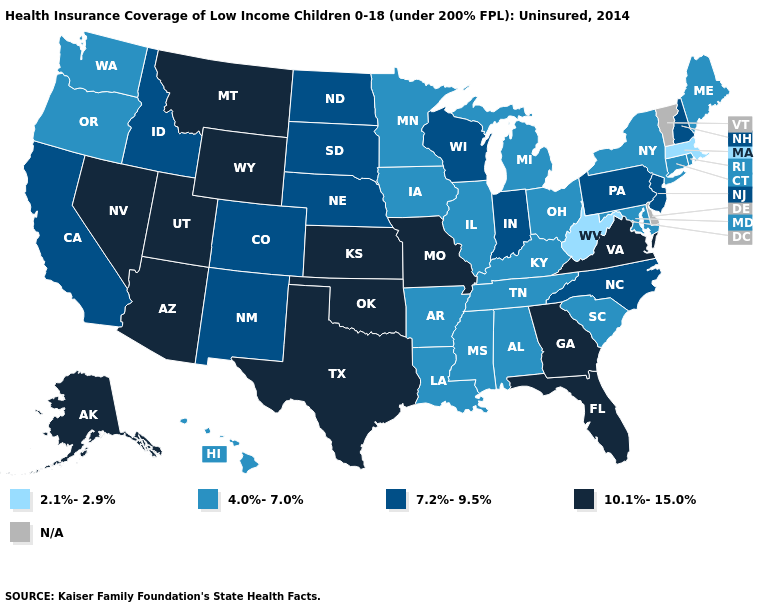Which states have the lowest value in the West?
Keep it brief. Hawaii, Oregon, Washington. How many symbols are there in the legend?
Keep it brief. 5. What is the highest value in the South ?
Short answer required. 10.1%-15.0%. What is the highest value in the USA?
Write a very short answer. 10.1%-15.0%. Which states have the lowest value in the USA?
Concise answer only. Massachusetts, West Virginia. What is the value of Nebraska?
Keep it brief. 7.2%-9.5%. Which states have the lowest value in the USA?
Give a very brief answer. Massachusetts, West Virginia. What is the value of Arizona?
Write a very short answer. 10.1%-15.0%. What is the highest value in the USA?
Answer briefly. 10.1%-15.0%. Among the states that border Oklahoma , does Missouri have the lowest value?
Concise answer only. No. What is the value of Michigan?
Quick response, please. 4.0%-7.0%. Name the states that have a value in the range 2.1%-2.9%?
Be succinct. Massachusetts, West Virginia. What is the value of Ohio?
Give a very brief answer. 4.0%-7.0%. Which states have the lowest value in the Northeast?
Quick response, please. Massachusetts. 